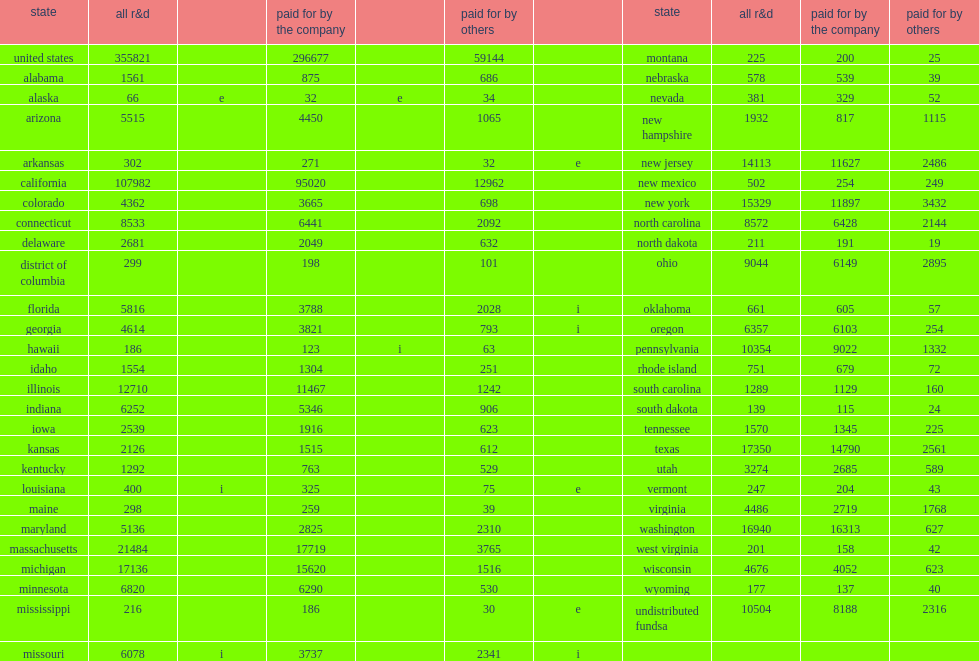In 2015, how many million dollars did companies report of domestic r&d paid for by the company? 296677.0. How many percent did businesses in california alone account for? 0.320281. 